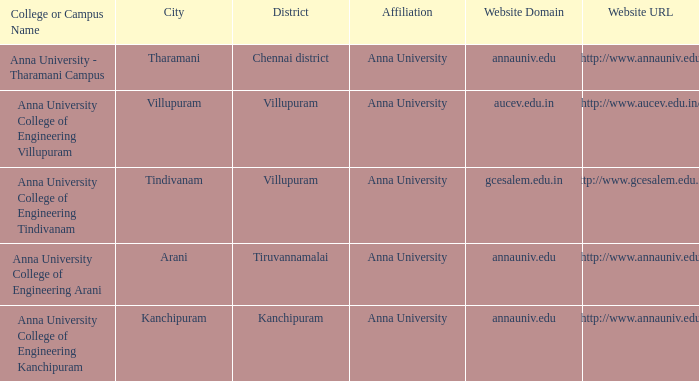What Weblink has a College or Campus Name of anna university college of engineering tindivanam? Http://www.gcesalem.edu.in. 